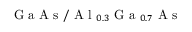<formula> <loc_0><loc_0><loc_500><loc_500>G a A s / A l _ { 0 . 3 } G a _ { 0 . 7 } A s</formula> 